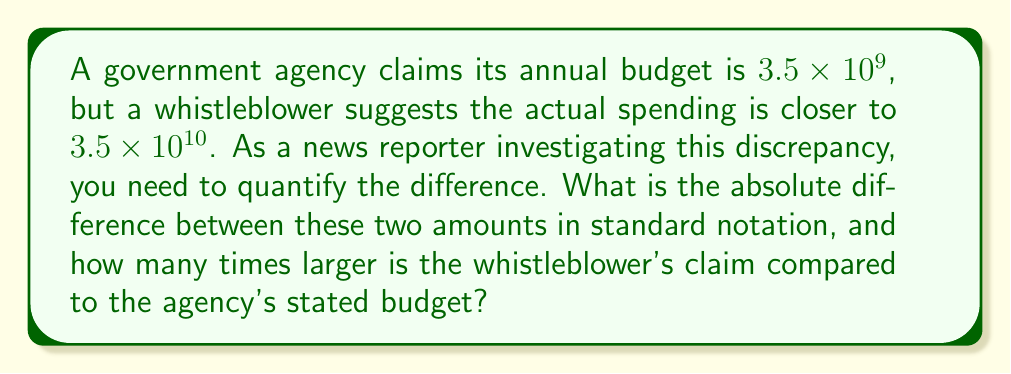Teach me how to tackle this problem. To solve this problem, we need to follow these steps:

1. Convert both numbers from scientific notation to standard notation:
   
   Agency's claim: $3.5 \times 10^9 = 3,500,000,000$
   Whistleblower's claim: $3.5 \times 10^{10} = 35,000,000,000$

2. Calculate the absolute difference:
   
   $35,000,000,000 - 3,500,000,000 = 31,500,000,000$

3. To determine how many times larger the whistleblower's claim is, divide the larger number by the smaller:
   
   $\frac{3.5 \times 10^{10}}{3.5 \times 10^9} = \frac{3.5}{3.5} \times \frac{10^{10}}{10^9} = 1 \times 10^1 = 10$

Therefore, the whistleblower's claim is 10 times larger than the agency's stated budget.
Answer: The absolute difference is $31,500,000,000, and the whistleblower's claim is 10 times larger than the agency's stated budget. 